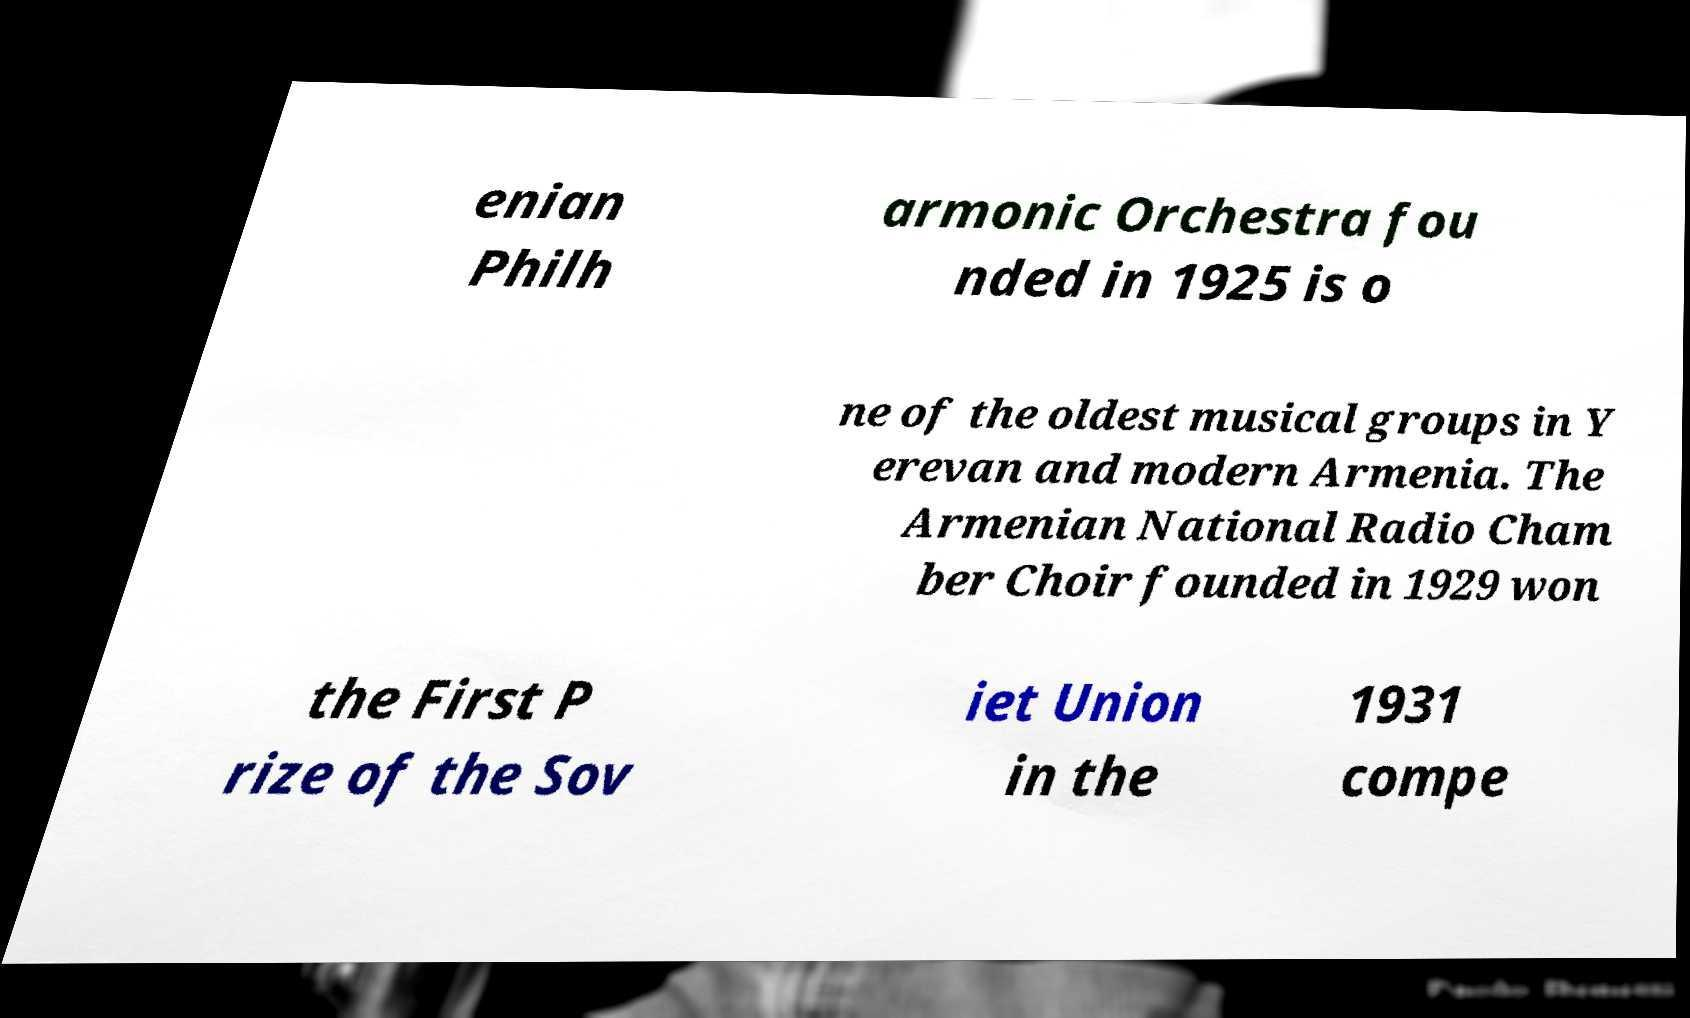There's text embedded in this image that I need extracted. Can you transcribe it verbatim? enian Philh armonic Orchestra fou nded in 1925 is o ne of the oldest musical groups in Y erevan and modern Armenia. The Armenian National Radio Cham ber Choir founded in 1929 won the First P rize of the Sov iet Union in the 1931 compe 